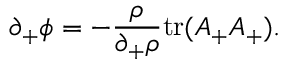Convert formula to latex. <formula><loc_0><loc_0><loc_500><loc_500>\partial _ { + } \phi = - { \frac { \rho } { \partial _ { + } \rho } } t r ( A _ { + } A _ { + } ) .</formula> 